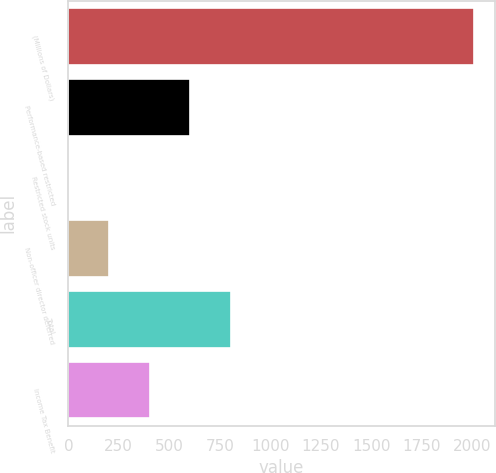<chart> <loc_0><loc_0><loc_500><loc_500><bar_chart><fcel>(Millions of Dollars)<fcel>Performance-based restricted<fcel>Restricted stock units<fcel>Non-officer director deferred<fcel>Total<fcel>Income Tax Benefit<nl><fcel>2010<fcel>603.7<fcel>1<fcel>201.9<fcel>804.6<fcel>402.8<nl></chart> 